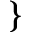Convert formula to latex. <formula><loc_0><loc_0><loc_500><loc_500>\}</formula> 